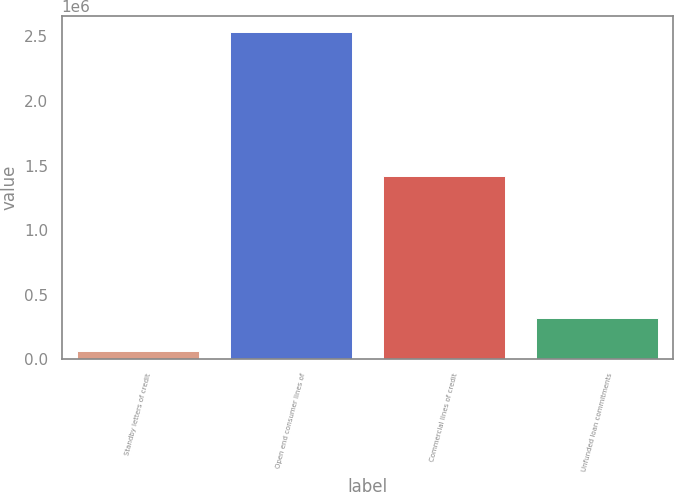Convert chart to OTSL. <chart><loc_0><loc_0><loc_500><loc_500><bar_chart><fcel>Standby letters of credit<fcel>Open end consumer lines of<fcel>Commercial lines of credit<fcel>Unfunded loan commitments<nl><fcel>60925<fcel>2.53169e+06<fcel>1.41975e+06<fcel>322419<nl></chart> 